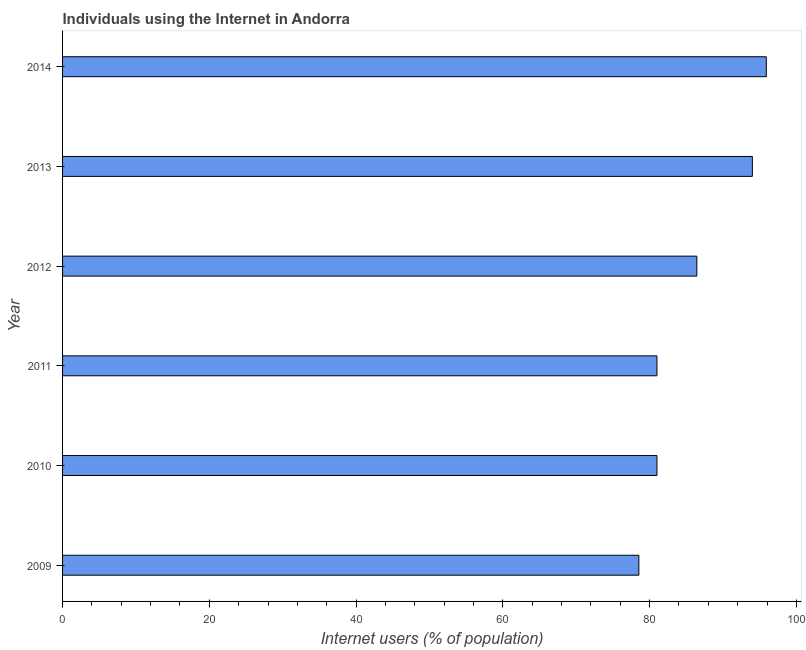Does the graph contain any zero values?
Offer a very short reply. No. Does the graph contain grids?
Your response must be concise. No. What is the title of the graph?
Give a very brief answer. Individuals using the Internet in Andorra. What is the label or title of the X-axis?
Make the answer very short. Internet users (% of population). What is the number of internet users in 2013?
Keep it short and to the point. 94. Across all years, what is the maximum number of internet users?
Your response must be concise. 95.9. Across all years, what is the minimum number of internet users?
Your response must be concise. 78.53. In which year was the number of internet users minimum?
Give a very brief answer. 2009. What is the sum of the number of internet users?
Ensure brevity in your answer.  516.86. What is the difference between the number of internet users in 2009 and 2013?
Ensure brevity in your answer.  -15.47. What is the average number of internet users per year?
Make the answer very short. 86.14. What is the median number of internet users?
Offer a very short reply. 83.72. Do a majority of the years between 2014 and 2011 (inclusive) have number of internet users greater than 40 %?
Keep it short and to the point. Yes. What is the ratio of the number of internet users in 2009 to that in 2012?
Your response must be concise. 0.91. Is the number of internet users in 2010 less than that in 2013?
Your answer should be very brief. Yes. What is the difference between the highest and the second highest number of internet users?
Offer a very short reply. 1.9. Is the sum of the number of internet users in 2010 and 2012 greater than the maximum number of internet users across all years?
Provide a succinct answer. Yes. What is the difference between the highest and the lowest number of internet users?
Make the answer very short. 17.37. What is the difference between two consecutive major ticks on the X-axis?
Give a very brief answer. 20. Are the values on the major ticks of X-axis written in scientific E-notation?
Give a very brief answer. No. What is the Internet users (% of population) in 2009?
Keep it short and to the point. 78.53. What is the Internet users (% of population) of 2012?
Ensure brevity in your answer.  86.43. What is the Internet users (% of population) in 2013?
Ensure brevity in your answer.  94. What is the Internet users (% of population) in 2014?
Keep it short and to the point. 95.9. What is the difference between the Internet users (% of population) in 2009 and 2010?
Offer a very short reply. -2.47. What is the difference between the Internet users (% of population) in 2009 and 2011?
Give a very brief answer. -2.47. What is the difference between the Internet users (% of population) in 2009 and 2012?
Provide a succinct answer. -7.9. What is the difference between the Internet users (% of population) in 2009 and 2013?
Provide a short and direct response. -15.47. What is the difference between the Internet users (% of population) in 2009 and 2014?
Make the answer very short. -17.37. What is the difference between the Internet users (% of population) in 2010 and 2012?
Give a very brief answer. -5.43. What is the difference between the Internet users (% of population) in 2010 and 2013?
Provide a succinct answer. -13. What is the difference between the Internet users (% of population) in 2010 and 2014?
Keep it short and to the point. -14.9. What is the difference between the Internet users (% of population) in 2011 and 2012?
Provide a short and direct response. -5.43. What is the difference between the Internet users (% of population) in 2011 and 2013?
Ensure brevity in your answer.  -13. What is the difference between the Internet users (% of population) in 2011 and 2014?
Your response must be concise. -14.9. What is the difference between the Internet users (% of population) in 2012 and 2013?
Your answer should be compact. -7.57. What is the difference between the Internet users (% of population) in 2012 and 2014?
Offer a terse response. -9.47. What is the difference between the Internet users (% of population) in 2013 and 2014?
Your answer should be very brief. -1.9. What is the ratio of the Internet users (% of population) in 2009 to that in 2010?
Offer a terse response. 0.97. What is the ratio of the Internet users (% of population) in 2009 to that in 2011?
Keep it short and to the point. 0.97. What is the ratio of the Internet users (% of population) in 2009 to that in 2012?
Offer a very short reply. 0.91. What is the ratio of the Internet users (% of population) in 2009 to that in 2013?
Your answer should be compact. 0.83. What is the ratio of the Internet users (% of population) in 2009 to that in 2014?
Make the answer very short. 0.82. What is the ratio of the Internet users (% of population) in 2010 to that in 2012?
Your response must be concise. 0.94. What is the ratio of the Internet users (% of population) in 2010 to that in 2013?
Offer a very short reply. 0.86. What is the ratio of the Internet users (% of population) in 2010 to that in 2014?
Your answer should be compact. 0.84. What is the ratio of the Internet users (% of population) in 2011 to that in 2012?
Offer a very short reply. 0.94. What is the ratio of the Internet users (% of population) in 2011 to that in 2013?
Ensure brevity in your answer.  0.86. What is the ratio of the Internet users (% of population) in 2011 to that in 2014?
Your answer should be very brief. 0.84. What is the ratio of the Internet users (% of population) in 2012 to that in 2014?
Ensure brevity in your answer.  0.9. 